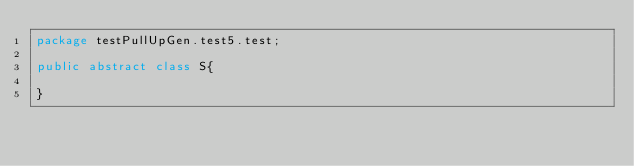<code> <loc_0><loc_0><loc_500><loc_500><_Java_>package testPullUpGen.test5.test;

public abstract class S{

}
</code> 